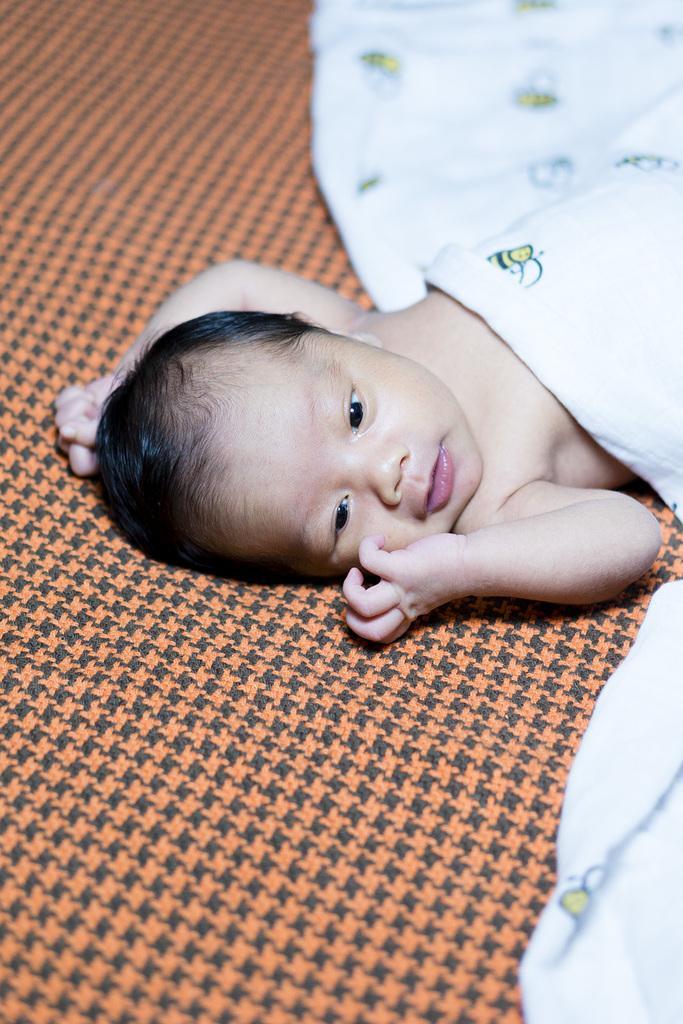Can you describe this image briefly? There is a baby laying on a bed. And this baby is partially covered with a white color cloth. 